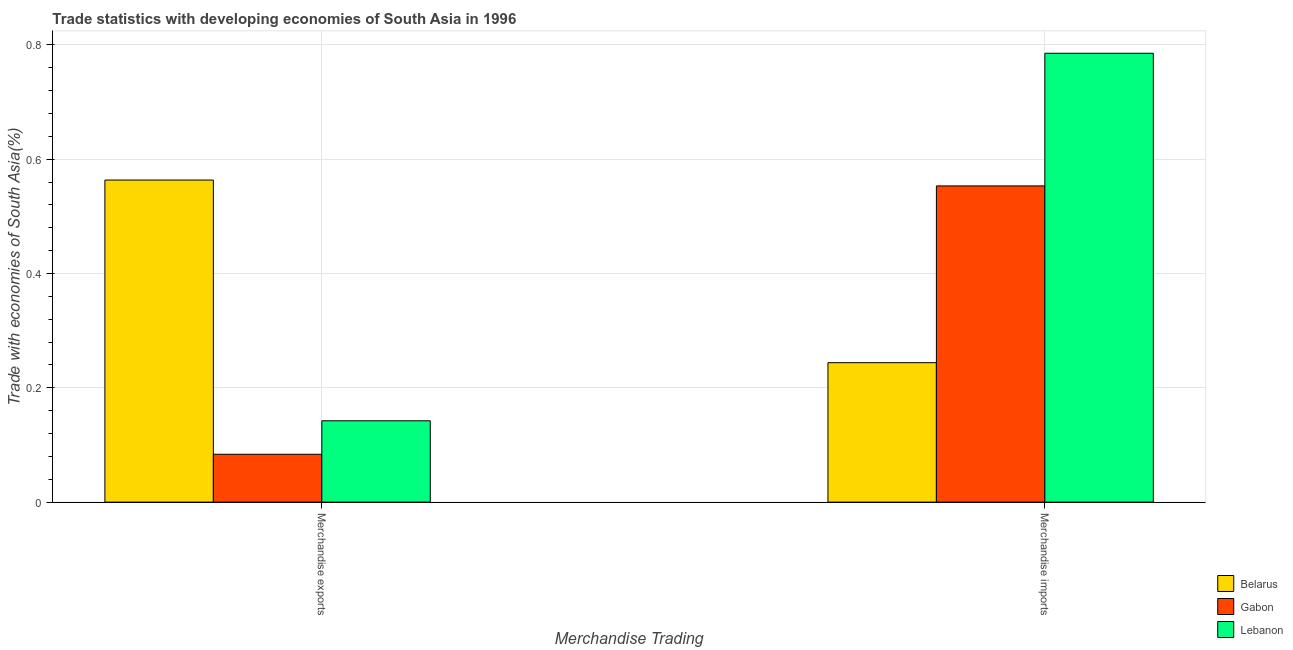Are the number of bars per tick equal to the number of legend labels?
Provide a succinct answer. Yes. How many bars are there on the 2nd tick from the right?
Ensure brevity in your answer.  3. What is the label of the 1st group of bars from the left?
Offer a terse response. Merchandise exports. What is the merchandise exports in Lebanon?
Your response must be concise. 0.14. Across all countries, what is the maximum merchandise exports?
Offer a terse response. 0.56. Across all countries, what is the minimum merchandise exports?
Your response must be concise. 0.08. In which country was the merchandise exports maximum?
Offer a very short reply. Belarus. In which country was the merchandise exports minimum?
Offer a terse response. Gabon. What is the total merchandise exports in the graph?
Your answer should be compact. 0.79. What is the difference between the merchandise imports in Lebanon and that in Belarus?
Keep it short and to the point. 0.54. What is the difference between the merchandise exports in Lebanon and the merchandise imports in Gabon?
Keep it short and to the point. -0.41. What is the average merchandise exports per country?
Your response must be concise. 0.26. What is the difference between the merchandise exports and merchandise imports in Belarus?
Your answer should be very brief. 0.32. In how many countries, is the merchandise exports greater than 0.7600000000000001 %?
Make the answer very short. 0. What is the ratio of the merchandise imports in Belarus to that in Gabon?
Your answer should be very brief. 0.44. Is the merchandise exports in Lebanon less than that in Belarus?
Keep it short and to the point. Yes. What does the 3rd bar from the left in Merchandise imports represents?
Ensure brevity in your answer.  Lebanon. What does the 1st bar from the right in Merchandise imports represents?
Provide a succinct answer. Lebanon. What is the difference between two consecutive major ticks on the Y-axis?
Give a very brief answer. 0.2. Are the values on the major ticks of Y-axis written in scientific E-notation?
Ensure brevity in your answer.  No. Does the graph contain any zero values?
Provide a short and direct response. No. Does the graph contain grids?
Offer a very short reply. Yes. What is the title of the graph?
Your answer should be compact. Trade statistics with developing economies of South Asia in 1996. Does "Peru" appear as one of the legend labels in the graph?
Offer a terse response. No. What is the label or title of the X-axis?
Provide a short and direct response. Merchandise Trading. What is the label or title of the Y-axis?
Provide a succinct answer. Trade with economies of South Asia(%). What is the Trade with economies of South Asia(%) of Belarus in Merchandise exports?
Give a very brief answer. 0.56. What is the Trade with economies of South Asia(%) in Gabon in Merchandise exports?
Your answer should be compact. 0.08. What is the Trade with economies of South Asia(%) of Lebanon in Merchandise exports?
Provide a short and direct response. 0.14. What is the Trade with economies of South Asia(%) in Belarus in Merchandise imports?
Provide a short and direct response. 0.24. What is the Trade with economies of South Asia(%) of Gabon in Merchandise imports?
Ensure brevity in your answer.  0.55. What is the Trade with economies of South Asia(%) of Lebanon in Merchandise imports?
Provide a short and direct response. 0.79. Across all Merchandise Trading, what is the maximum Trade with economies of South Asia(%) of Belarus?
Your response must be concise. 0.56. Across all Merchandise Trading, what is the maximum Trade with economies of South Asia(%) in Gabon?
Make the answer very short. 0.55. Across all Merchandise Trading, what is the maximum Trade with economies of South Asia(%) in Lebanon?
Give a very brief answer. 0.79. Across all Merchandise Trading, what is the minimum Trade with economies of South Asia(%) of Belarus?
Offer a terse response. 0.24. Across all Merchandise Trading, what is the minimum Trade with economies of South Asia(%) of Gabon?
Your answer should be compact. 0.08. Across all Merchandise Trading, what is the minimum Trade with economies of South Asia(%) of Lebanon?
Ensure brevity in your answer.  0.14. What is the total Trade with economies of South Asia(%) of Belarus in the graph?
Your response must be concise. 0.81. What is the total Trade with economies of South Asia(%) in Gabon in the graph?
Offer a terse response. 0.64. What is the total Trade with economies of South Asia(%) in Lebanon in the graph?
Your response must be concise. 0.93. What is the difference between the Trade with economies of South Asia(%) of Belarus in Merchandise exports and that in Merchandise imports?
Your answer should be very brief. 0.32. What is the difference between the Trade with economies of South Asia(%) of Gabon in Merchandise exports and that in Merchandise imports?
Provide a succinct answer. -0.47. What is the difference between the Trade with economies of South Asia(%) of Lebanon in Merchandise exports and that in Merchandise imports?
Offer a very short reply. -0.64. What is the difference between the Trade with economies of South Asia(%) of Belarus in Merchandise exports and the Trade with economies of South Asia(%) of Gabon in Merchandise imports?
Your answer should be compact. 0.01. What is the difference between the Trade with economies of South Asia(%) in Belarus in Merchandise exports and the Trade with economies of South Asia(%) in Lebanon in Merchandise imports?
Give a very brief answer. -0.22. What is the difference between the Trade with economies of South Asia(%) in Gabon in Merchandise exports and the Trade with economies of South Asia(%) in Lebanon in Merchandise imports?
Provide a short and direct response. -0.7. What is the average Trade with economies of South Asia(%) in Belarus per Merchandise Trading?
Provide a succinct answer. 0.4. What is the average Trade with economies of South Asia(%) of Gabon per Merchandise Trading?
Offer a terse response. 0.32. What is the average Trade with economies of South Asia(%) of Lebanon per Merchandise Trading?
Give a very brief answer. 0.46. What is the difference between the Trade with economies of South Asia(%) of Belarus and Trade with economies of South Asia(%) of Gabon in Merchandise exports?
Offer a very short reply. 0.48. What is the difference between the Trade with economies of South Asia(%) in Belarus and Trade with economies of South Asia(%) in Lebanon in Merchandise exports?
Your response must be concise. 0.42. What is the difference between the Trade with economies of South Asia(%) of Gabon and Trade with economies of South Asia(%) of Lebanon in Merchandise exports?
Offer a terse response. -0.06. What is the difference between the Trade with economies of South Asia(%) in Belarus and Trade with economies of South Asia(%) in Gabon in Merchandise imports?
Provide a succinct answer. -0.31. What is the difference between the Trade with economies of South Asia(%) in Belarus and Trade with economies of South Asia(%) in Lebanon in Merchandise imports?
Keep it short and to the point. -0.54. What is the difference between the Trade with economies of South Asia(%) in Gabon and Trade with economies of South Asia(%) in Lebanon in Merchandise imports?
Your answer should be very brief. -0.23. What is the ratio of the Trade with economies of South Asia(%) in Belarus in Merchandise exports to that in Merchandise imports?
Ensure brevity in your answer.  2.31. What is the ratio of the Trade with economies of South Asia(%) in Gabon in Merchandise exports to that in Merchandise imports?
Ensure brevity in your answer.  0.15. What is the ratio of the Trade with economies of South Asia(%) in Lebanon in Merchandise exports to that in Merchandise imports?
Your answer should be compact. 0.18. What is the difference between the highest and the second highest Trade with economies of South Asia(%) in Belarus?
Provide a short and direct response. 0.32. What is the difference between the highest and the second highest Trade with economies of South Asia(%) of Gabon?
Ensure brevity in your answer.  0.47. What is the difference between the highest and the second highest Trade with economies of South Asia(%) of Lebanon?
Provide a succinct answer. 0.64. What is the difference between the highest and the lowest Trade with economies of South Asia(%) in Belarus?
Keep it short and to the point. 0.32. What is the difference between the highest and the lowest Trade with economies of South Asia(%) in Gabon?
Your answer should be very brief. 0.47. What is the difference between the highest and the lowest Trade with economies of South Asia(%) of Lebanon?
Offer a very short reply. 0.64. 